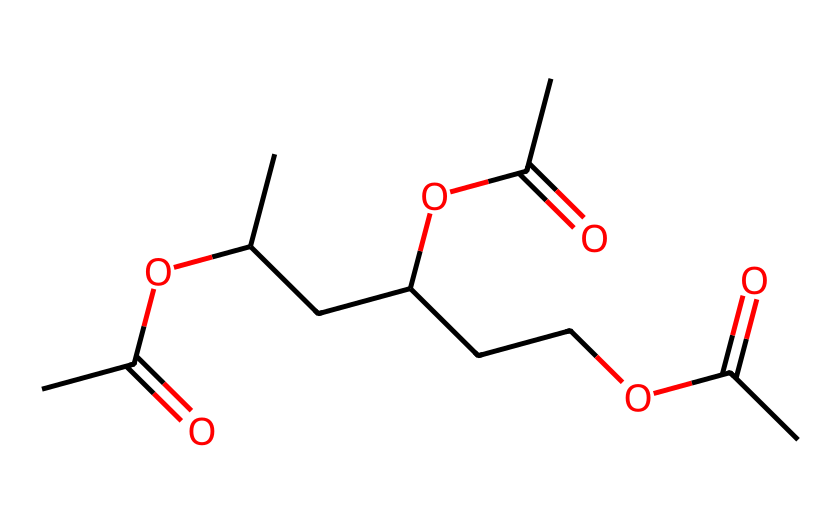what is the chemical name of this compound? The SMILES representation specifies a polymer composed of repeat units of acetate groups. This structure indicates that it is derived from vinyl acetate, leading to the conclusion that the compound is polyvinyl acetate.
Answer: polyvinyl acetate how many carbon atoms are in the monomer unit? By analyzing the SMILES representation, we can count the number of carbon atoms within the repeating unit. Each unit has four carbon atoms, and there are three similar units in the given structure, totaling twelve carbon atoms.
Answer: twelve what functional groups are present in this chemical? The SMILES shows the presence of ester groups from the acetate moieties, specifically the -O-C(=O) functional groups. These esters are characteristic of the polyvinyl acetate structure.
Answer: ester how many oxygen atoms are present in one repeating unit? Each acetate functional group has two oxygen atoms (from -O and -C(=O)). Since the structure has three repeating units with one oxygen each from the alkyl part, we find that there are a total of six oxygen atoms per repeating unit.
Answer: six what type of polymer is polyvinyl acetate? Based on its structure and properties, polyvinyl acetate is classified as a thermoplastic polymer. This classification arises because of its ability to soften upon heating and harden as it cools.
Answer: thermoplastic what is the significance of polyvinyl acetate in vintage photography? Polyvinyl acetate is commonly used in adhesives, particularly for mounting photographs due to its clear drying characteristics and non-yellowing properties, preserving the integrity of vintage photographs over time.
Answer: adhesive 